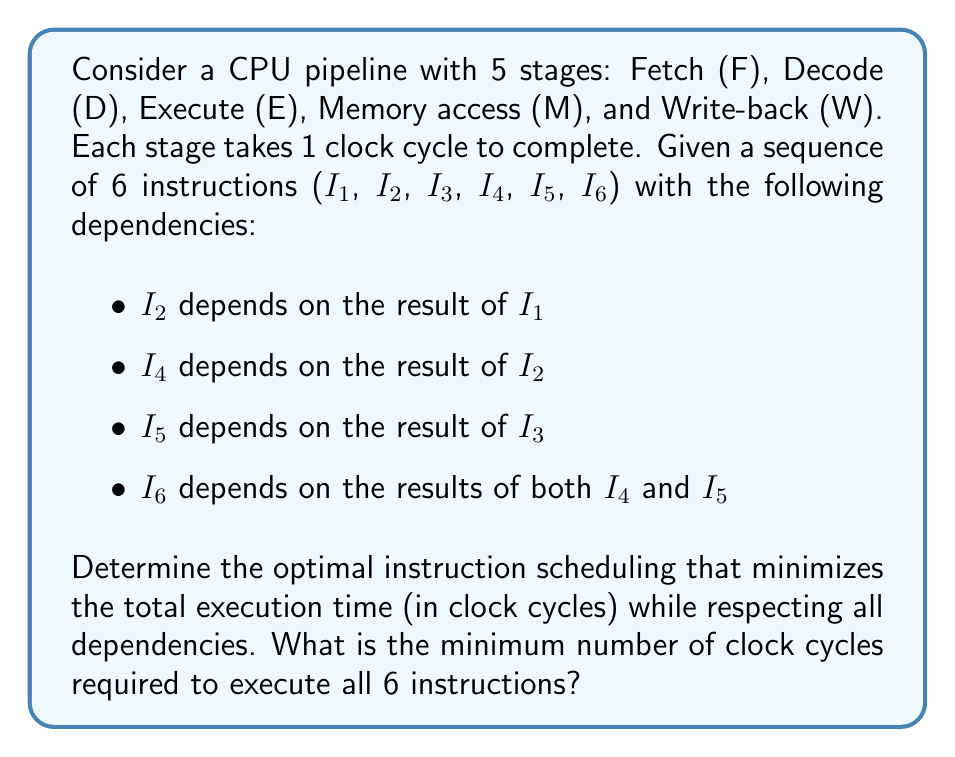Solve this math problem. To solve this problem, we need to consider the dependencies between instructions and optimize the scheduling to minimize pipeline stalls. Let's approach this step-by-step:

1. First, let's visualize the dependencies:

   I1 → I2 → I4 ↘
                I6
   I3 → I5 ↗

2. We'll use a pipeline diagram to schedule the instructions. Each column represents a clock cycle, and each row represents a pipeline stage.

3. Start with I1, as it has no dependencies:

   Cycle: 1 2 3 4 5 6 7 8 9 10
   F     I1
   D        I1
   E           I1
   M              I1
   W                 I1

4. I2 depends on I1, so it can start in the Fetch stage when I1 is in the Execute stage:

   Cycle: 1 2 3 4 5 6 7 8 9 10
   F     I1 I3 I2
   D        I1 I3 I2
   E           I1 I3 I2
   M              I1 I3 I2
   W                 I1 I3 I2

5. I3 can be fetched immediately after I1, as it has no dependencies on I1 or I2.

6. I4 depends on I2, so it must wait until I2 completes the Execute stage:

   Cycle: 1 2 3 4 5 6 7 8 9 10
   F     I1 I3 I2 I5 I4
   D        I1 I3 I2 I5 I4
   E           I1 I3 I2 I5 I4
   M              I1 I3 I2 I5 I4
   W                 I1 I3 I2 I5 I4

7. I5 depends on I3, so it can be fetched right after I3.

8. I6 depends on both I4 and I5, so it must wait until both complete the Execute stage:

   Cycle: 1 2 3 4 5 6 7 8 9 10
   F     I1 I3 I2 I5 I4 -- I6
   D        I1 I3 I2 I5 I4 -- I6
   E           I1 I3 I2 I5 I4 -- I6
   M              I1 I3 I2 I5 I4 -- I6
   W                 I1 I3 I2 I5 I4 -- I6

9. Count the total number of cycles: The last instruction (I6) completes the Write-back stage in cycle 10.

Therefore, the optimal scheduling requires 10 clock cycles to execute all 6 instructions while respecting all dependencies.
Answer: 10 clock cycles 